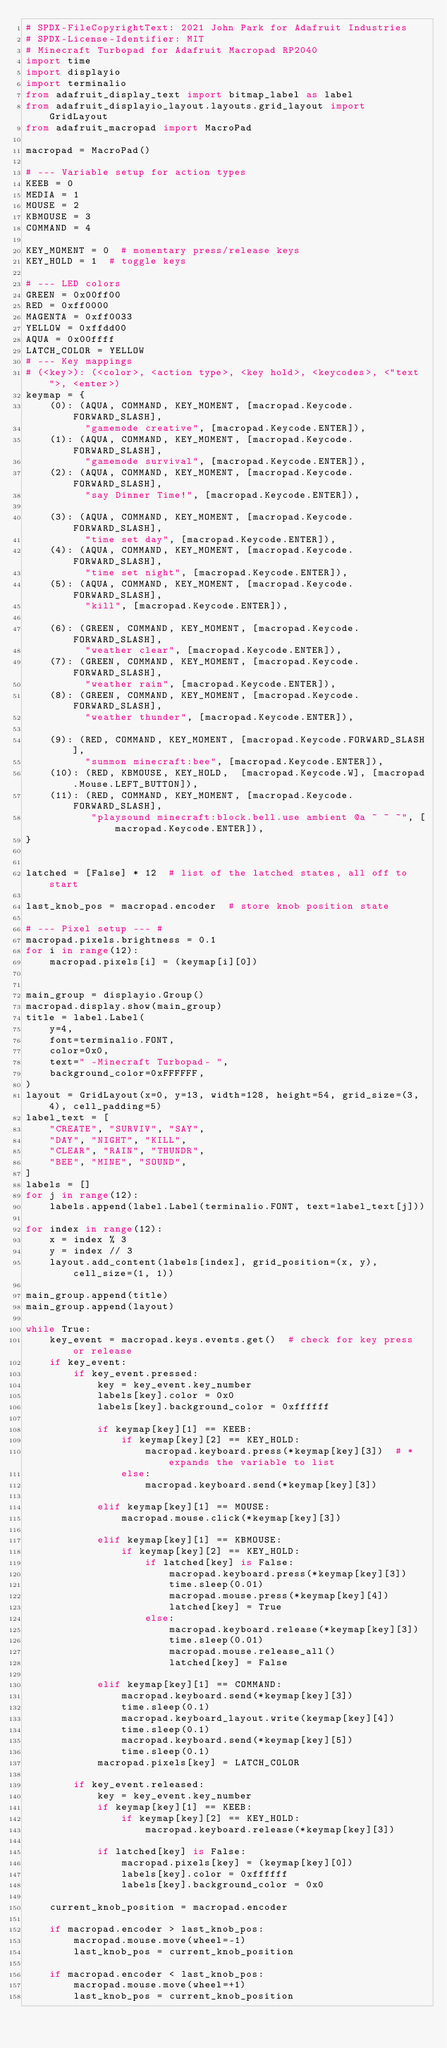<code> <loc_0><loc_0><loc_500><loc_500><_Python_># SPDX-FileCopyrightText: 2021 John Park for Adafruit Industries
# SPDX-License-Identifier: MIT
# Minecraft Turbopad for Adafruit Macropad RP2040
import time
import displayio
import terminalio
from adafruit_display_text import bitmap_label as label
from adafruit_displayio_layout.layouts.grid_layout import GridLayout
from adafruit_macropad import MacroPad

macropad = MacroPad()

# --- Variable setup for action types
KEEB = 0
MEDIA = 1
MOUSE = 2
KBMOUSE = 3
COMMAND = 4

KEY_MOMENT = 0  # momentary press/release keys
KEY_HOLD = 1  # toggle keys

# --- LED colors
GREEN = 0x00ff00
RED = 0xff0000
MAGENTA = 0xff0033
YELLOW = 0xffdd00
AQUA = 0x00ffff
LATCH_COLOR = YELLOW
# --- Key mappings
# (<key>): (<color>, <action type>, <key hold>, <keycodes>, <"text">, <enter>)
keymap = {
    (0): (AQUA, COMMAND, KEY_MOMENT, [macropad.Keycode.FORWARD_SLASH],
          "gamemode creative", [macropad.Keycode.ENTER]),
    (1): (AQUA, COMMAND, KEY_MOMENT, [macropad.Keycode.FORWARD_SLASH],
          "gamemode survival", [macropad.Keycode.ENTER]),
    (2): (AQUA, COMMAND, KEY_MOMENT, [macropad.Keycode.FORWARD_SLASH],
          "say Dinner Time!", [macropad.Keycode.ENTER]),

    (3): (AQUA, COMMAND, KEY_MOMENT, [macropad.Keycode.FORWARD_SLASH],
          "time set day", [macropad.Keycode.ENTER]),
    (4): (AQUA, COMMAND, KEY_MOMENT, [macropad.Keycode.FORWARD_SLASH],
          "time set night", [macropad.Keycode.ENTER]),
    (5): (AQUA, COMMAND, KEY_MOMENT, [macropad.Keycode.FORWARD_SLASH],
          "kill", [macropad.Keycode.ENTER]),

    (6): (GREEN, COMMAND, KEY_MOMENT, [macropad.Keycode.FORWARD_SLASH],
          "weather clear", [macropad.Keycode.ENTER]),
    (7): (GREEN, COMMAND, KEY_MOMENT, [macropad.Keycode.FORWARD_SLASH],
          "weather rain", [macropad.Keycode.ENTER]),
    (8): (GREEN, COMMAND, KEY_MOMENT, [macropad.Keycode.FORWARD_SLASH],
          "weather thunder", [macropad.Keycode.ENTER]),

    (9): (RED, COMMAND, KEY_MOMENT, [macropad.Keycode.FORWARD_SLASH],
          "summon minecraft:bee", [macropad.Keycode.ENTER]),
    (10): (RED, KBMOUSE, KEY_HOLD,  [macropad.Keycode.W], [macropad.Mouse.LEFT_BUTTON]),
    (11): (RED, COMMAND, KEY_MOMENT, [macropad.Keycode.FORWARD_SLASH],
           "playsound minecraft:block.bell.use ambient @a ~ ~ ~", [macropad.Keycode.ENTER]),
}


latched = [False] * 12  # list of the latched states, all off to start

last_knob_pos = macropad.encoder  # store knob position state

# --- Pixel setup --- #
macropad.pixels.brightness = 0.1
for i in range(12):
    macropad.pixels[i] = (keymap[i][0])


main_group = displayio.Group()
macropad.display.show(main_group)
title = label.Label(
    y=4,
    font=terminalio.FONT,
    color=0x0,
    text=" -Minecraft Turbopad- ",
    background_color=0xFFFFFF,
)
layout = GridLayout(x=0, y=13, width=128, height=54, grid_size=(3, 4), cell_padding=5)
label_text = [
    "CREATE", "SURVIV", "SAY",
    "DAY", "NIGHT", "KILL",
    "CLEAR", "RAIN", "THUNDR",
    "BEE", "MINE", "SOUND",
]
labels = []
for j in range(12):
    labels.append(label.Label(terminalio.FONT, text=label_text[j]))

for index in range(12):
    x = index % 3
    y = index // 3
    layout.add_content(labels[index], grid_position=(x, y), cell_size=(1, 1))

main_group.append(title)
main_group.append(layout)

while True:
    key_event = macropad.keys.events.get()  # check for key press or release
    if key_event:
        if key_event.pressed:
            key = key_event.key_number
            labels[key].color = 0x0
            labels[key].background_color = 0xffffff

            if keymap[key][1] == KEEB:
                if keymap[key][2] == KEY_HOLD:
                    macropad.keyboard.press(*keymap[key][3])  # * expands the variable to list
                else:
                    macropad.keyboard.send(*keymap[key][3])

            elif keymap[key][1] == MOUSE:
                macropad.mouse.click(*keymap[key][3])

            elif keymap[key][1] == KBMOUSE:
                if keymap[key][2] == KEY_HOLD:
                    if latched[key] is False:
                        macropad.keyboard.press(*keymap[key][3])
                        time.sleep(0.01)
                        macropad.mouse.press(*keymap[key][4])
                        latched[key] = True
                    else:
                        macropad.keyboard.release(*keymap[key][3])
                        time.sleep(0.01)
                        macropad.mouse.release_all()
                        latched[key] = False

            elif keymap[key][1] == COMMAND:
                macropad.keyboard.send(*keymap[key][3])
                time.sleep(0.1)
                macropad.keyboard_layout.write(keymap[key][4])
                time.sleep(0.1)
                macropad.keyboard.send(*keymap[key][5])
                time.sleep(0.1)
            macropad.pixels[key] = LATCH_COLOR

        if key_event.released:
            key = key_event.key_number
            if keymap[key][1] == KEEB:
                if keymap[key][2] == KEY_HOLD:
                    macropad.keyboard.release(*keymap[key][3])

            if latched[key] is False:
                macropad.pixels[key] = (keymap[key][0])
                labels[key].color = 0xffffff
                labels[key].background_color = 0x0

    current_knob_position = macropad.encoder

    if macropad.encoder > last_knob_pos:
        macropad.mouse.move(wheel=-1)
        last_knob_pos = current_knob_position

    if macropad.encoder < last_knob_pos:
        macropad.mouse.move(wheel=+1)
        last_knob_pos = current_knob_position
</code> 